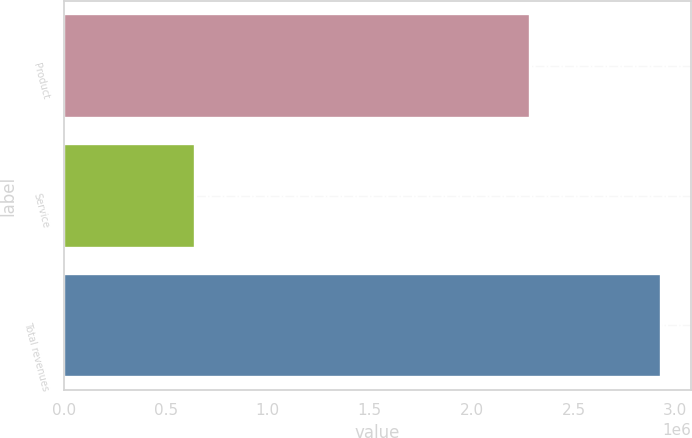Convert chart. <chart><loc_0><loc_0><loc_500><loc_500><bar_chart><fcel>Product<fcel>Service<fcel>Total revenues<nl><fcel>2.28644e+06<fcel>642971<fcel>2.92941e+06<nl></chart> 